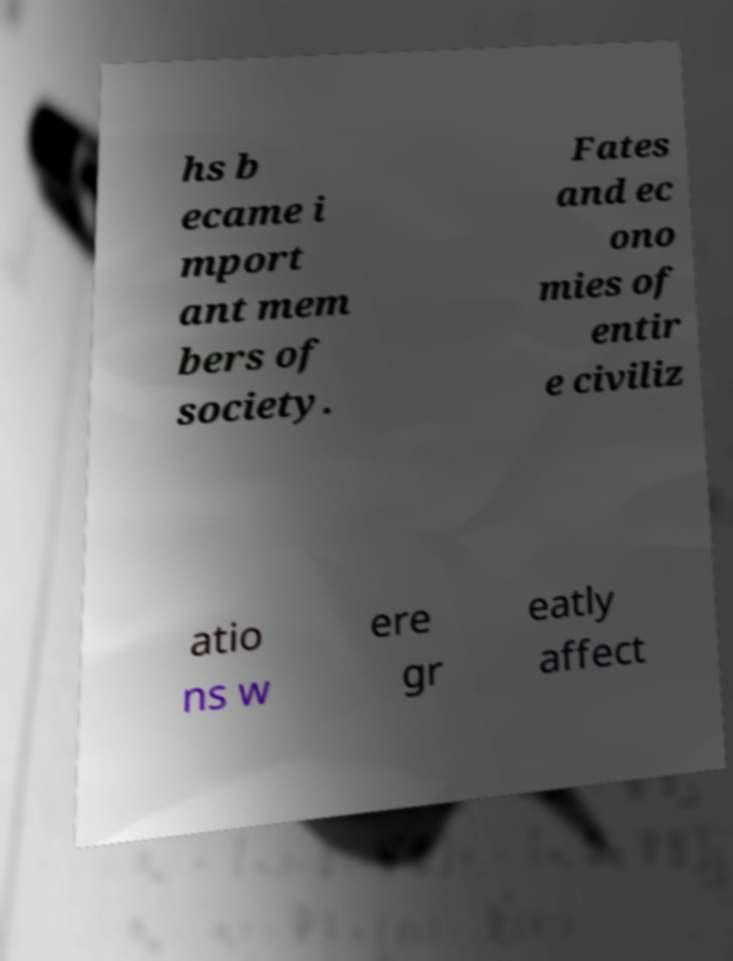There's text embedded in this image that I need extracted. Can you transcribe it verbatim? hs b ecame i mport ant mem bers of society. Fates and ec ono mies of entir e civiliz atio ns w ere gr eatly affect 